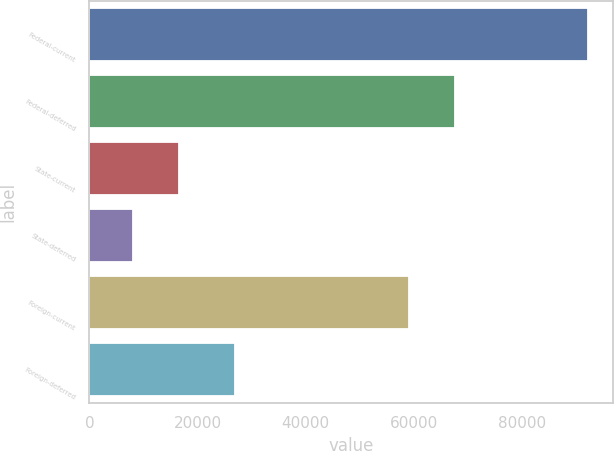<chart> <loc_0><loc_0><loc_500><loc_500><bar_chart><fcel>Federal-current<fcel>Federal-deferred<fcel>State-current<fcel>State-deferred<fcel>Foreign-current<fcel>Foreign-deferred<nl><fcel>92237<fcel>67588.1<fcel>16474.1<fcel>8056<fcel>59170<fcel>26935<nl></chart> 